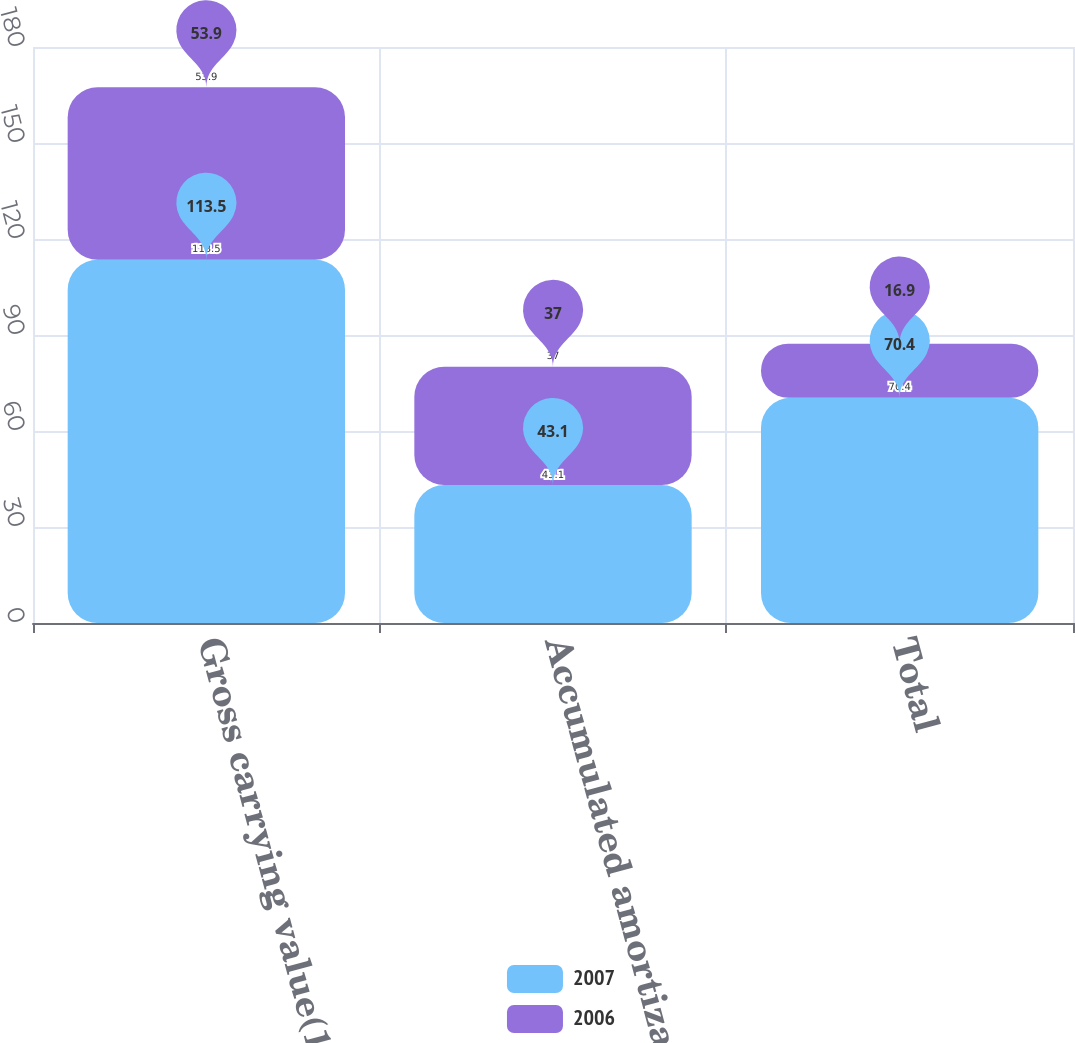Convert chart to OTSL. <chart><loc_0><loc_0><loc_500><loc_500><stacked_bar_chart><ecel><fcel>Gross carrying value(1)<fcel>Accumulated amortization<fcel>Total<nl><fcel>2007<fcel>113.5<fcel>43.1<fcel>70.4<nl><fcel>2006<fcel>53.9<fcel>37<fcel>16.9<nl></chart> 